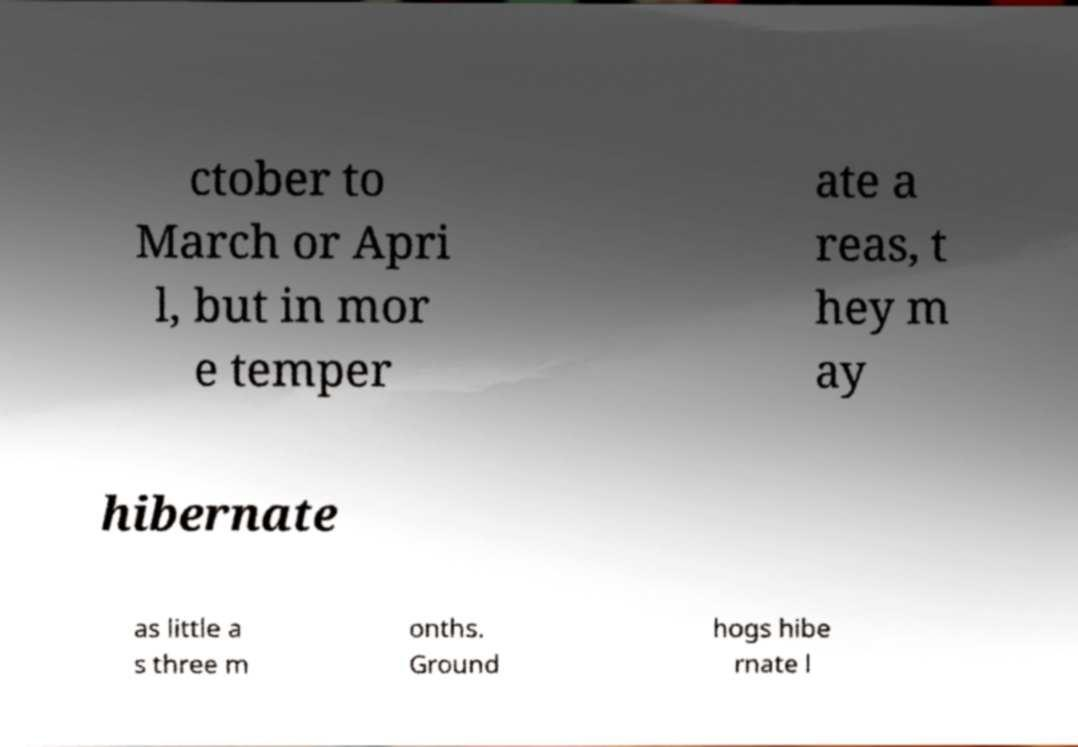I need the written content from this picture converted into text. Can you do that? ctober to March or Apri l, but in mor e temper ate a reas, t hey m ay hibernate as little a s three m onths. Ground hogs hibe rnate l 